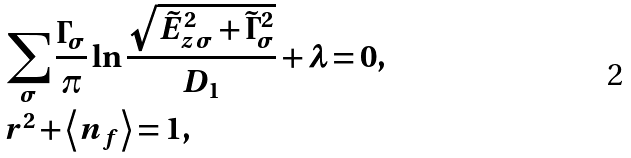<formula> <loc_0><loc_0><loc_500><loc_500>& \sum _ { \sigma } \frac { \Gamma _ { \sigma } } { \pi } \ln \frac { \sqrt { \tilde { E } _ { z \sigma } ^ { 2 } + \tilde { \Gamma } _ { \sigma } ^ { 2 } } } { D _ { 1 } } + \lambda = 0 , \\ & r ^ { 2 } + \left \langle n _ { f } \right \rangle = 1 ,</formula> 